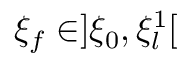Convert formula to latex. <formula><loc_0><loc_0><loc_500><loc_500>\xi _ { f } \in ] \xi _ { 0 } , \xi _ { l } ^ { 1 } [</formula> 